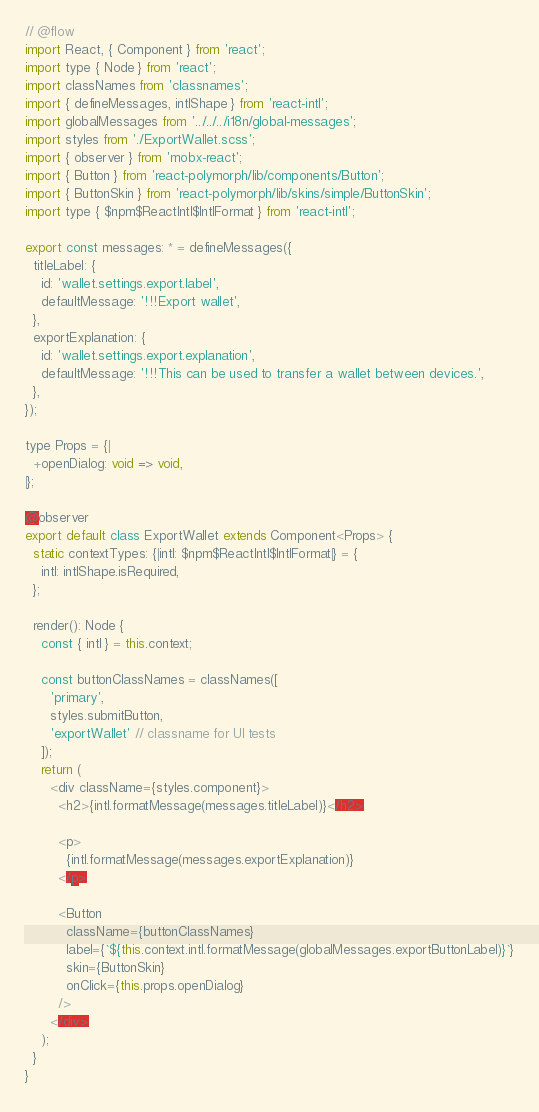<code> <loc_0><loc_0><loc_500><loc_500><_JavaScript_>// @flow
import React, { Component } from 'react';
import type { Node } from 'react';
import classNames from 'classnames';
import { defineMessages, intlShape } from 'react-intl';
import globalMessages from '../../../i18n/global-messages';
import styles from './ExportWallet.scss';
import { observer } from 'mobx-react';
import { Button } from 'react-polymorph/lib/components/Button';
import { ButtonSkin } from 'react-polymorph/lib/skins/simple/ButtonSkin';
import type { $npm$ReactIntl$IntlFormat } from 'react-intl';

export const messages: * = defineMessages({
  titleLabel: {
    id: 'wallet.settings.export.label',
    defaultMessage: '!!!Export wallet',
  },
  exportExplanation: {
    id: 'wallet.settings.export.explanation',
    defaultMessage: '!!!This can be used to transfer a wallet between devices.',
  },
});

type Props = {|
  +openDialog: void => void,
|};

@observer
export default class ExportWallet extends Component<Props> {
  static contextTypes: {|intl: $npm$ReactIntl$IntlFormat|} = {
    intl: intlShape.isRequired,
  };

  render(): Node {
    const { intl } = this.context;

    const buttonClassNames = classNames([
      'primary',
      styles.submitButton,
      'exportWallet' // classname for UI tests
    ]);
    return (
      <div className={styles.component}>
        <h2>{intl.formatMessage(messages.titleLabel)}</h2>

        <p>
          {intl.formatMessage(messages.exportExplanation)}
        </p>

        <Button
          className={buttonClassNames}
          label={`${this.context.intl.formatMessage(globalMessages.exportButtonLabel)}`}
          skin={ButtonSkin}
          onClick={this.props.openDialog}
        />
      </div>
    );
  }
}
</code> 